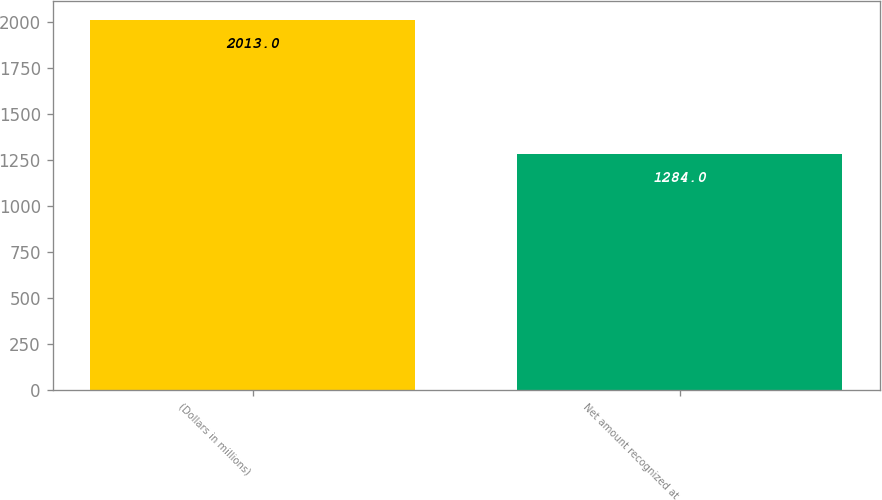Convert chart. <chart><loc_0><loc_0><loc_500><loc_500><bar_chart><fcel>(Dollars in millions)<fcel>Net amount recognized at<nl><fcel>2013<fcel>1284<nl></chart> 